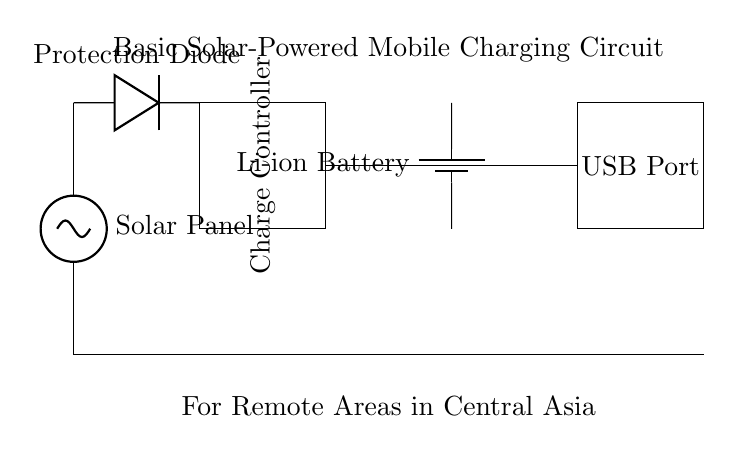What is the main function of the solar panel in this circuit? The solar panel converts sunlight into electrical energy, providing the necessary power to charge the battery.
Answer: energy conversion What type of battery is used in the circuit? The circuit diagram labels the battery as a lithium-ion battery, which is commonly used for energy storage in mobile devices.
Answer: Li-ion Battery Which component protects the circuit from reverse polarity? The protection diode is placed in the circuit to prevent current from flowing back into the solar panel when it is not generating power.
Answer: Protection Diode How many main components are in the circuit? The circuit features five main components: solar panel, protection diode, charge controller, lithium-ion battery, and USB port.
Answer: five Explain the role of the charge controller. The charge controller regulates the voltage and current coming from the solar panel to ensure that the battery is charged safely and efficiently, preventing overcharging and potential damage to the battery.
Answer: regulates charging What is the output connection type for mobile device charging? The USB port is the interface in the circuit that allows for charging mobile devices, which is a standard connection type for these devices.
Answer: USB Port 